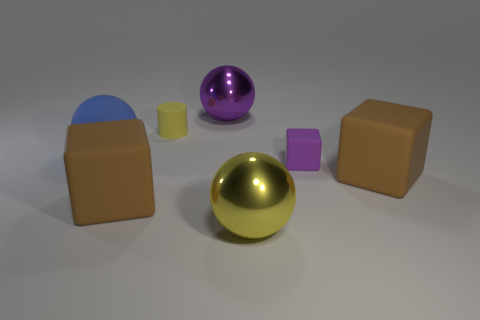What is the yellow object that is in front of the small matte object that is on the right side of the large yellow metallic sphere made of? The yellow object in question, which appears in front of the small matte object to the right of the large yellow metallic sphere, seems to be composed of a plastic or similar polymer material, discernible by its opaque surface and reflection properties, which are distinct from the metallic sheen of the sphere. 